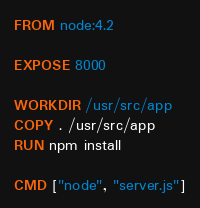<code> <loc_0><loc_0><loc_500><loc_500><_Dockerfile_>FROM node:4.2

EXPOSE 8000

WORKDIR /usr/src/app
COPY . /usr/src/app
RUN npm install

CMD ["node", "server.js"]
</code> 